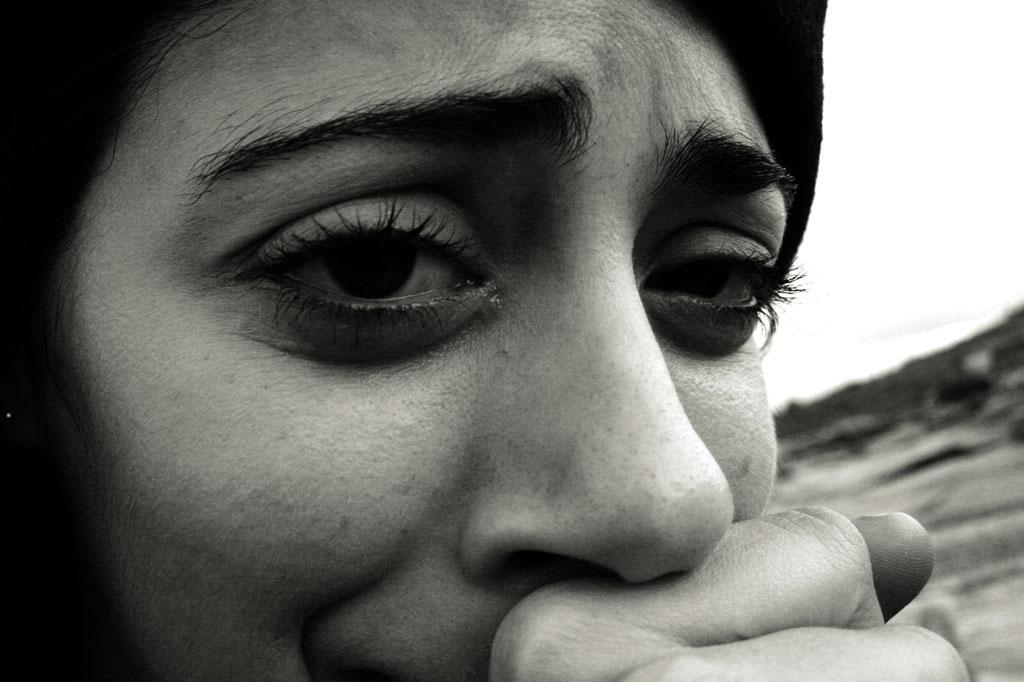What is the color scheme of the image? The image is black and white. Who is present in the image? There is a girl in the image. What is the girl doing in the image? The girl is crying. What is the girl doing with her hand in the image? The girl has her hand near her mouth. What type of poison is the girl holding in the image? There is no poison present in the image; the girl is simply crying with her hand near her mouth. 